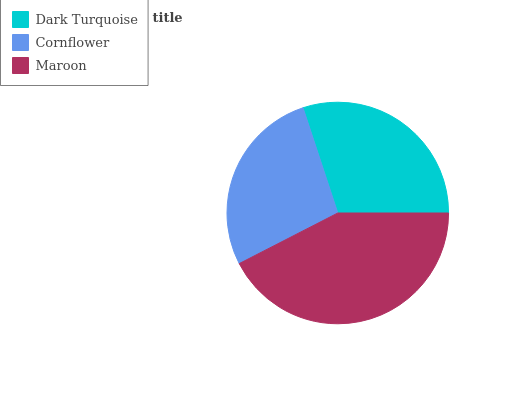Is Cornflower the minimum?
Answer yes or no. Yes. Is Maroon the maximum?
Answer yes or no. Yes. Is Maroon the minimum?
Answer yes or no. No. Is Cornflower the maximum?
Answer yes or no. No. Is Maroon greater than Cornflower?
Answer yes or no. Yes. Is Cornflower less than Maroon?
Answer yes or no. Yes. Is Cornflower greater than Maroon?
Answer yes or no. No. Is Maroon less than Cornflower?
Answer yes or no. No. Is Dark Turquoise the high median?
Answer yes or no. Yes. Is Dark Turquoise the low median?
Answer yes or no. Yes. Is Cornflower the high median?
Answer yes or no. No. Is Cornflower the low median?
Answer yes or no. No. 